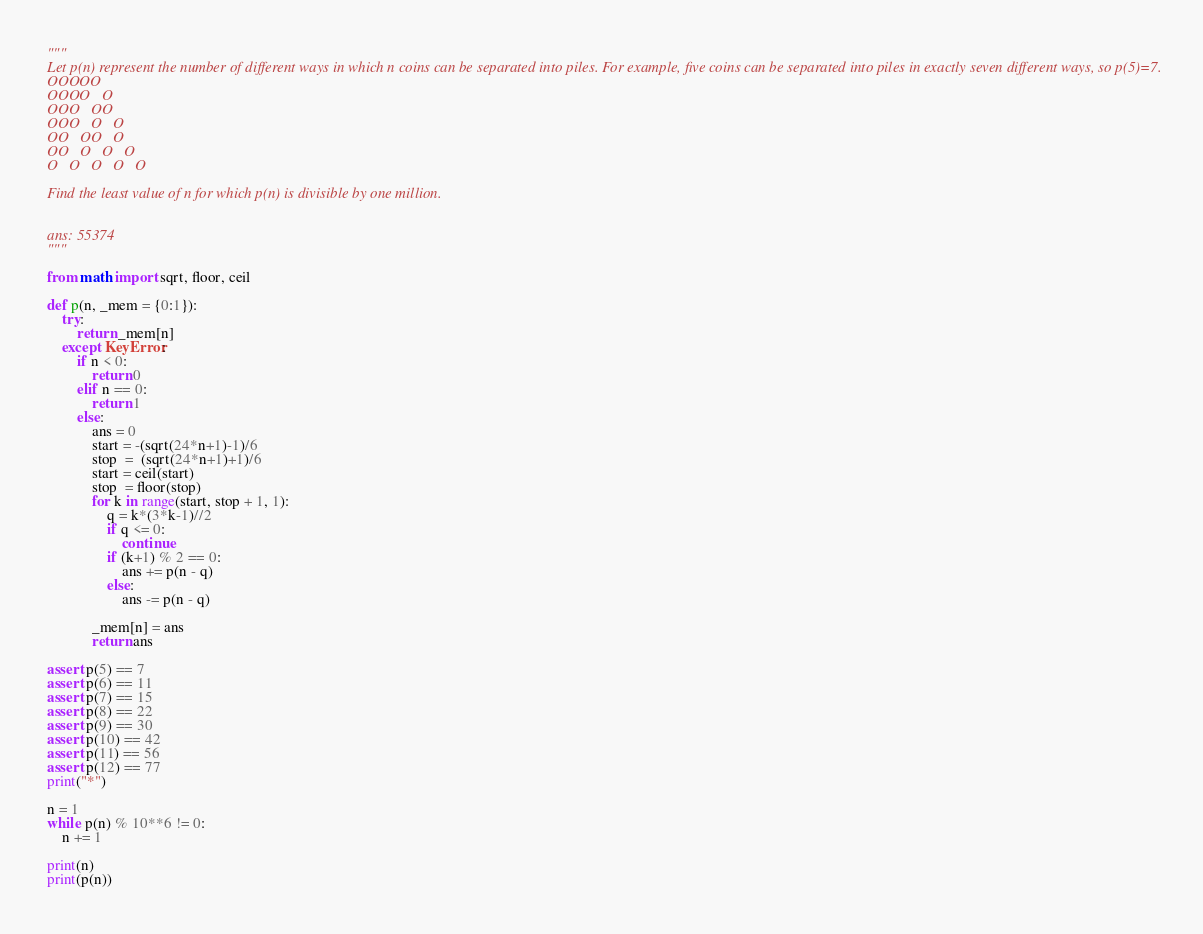<code> <loc_0><loc_0><loc_500><loc_500><_Python_>"""
Let p(n) represent the number of different ways in which n coins can be separated into piles. For example, five coins can be separated into piles in exactly seven different ways, so p(5)=7.
OOOOO
OOOO   O
OOO   OO
OOO   O   O
OO   OO   O
OO   O   O   O
O   O   O   O   O

Find the least value of n for which p(n) is divisible by one million.


ans: 55374
"""

from math import sqrt, floor, ceil

def p(n, _mem = {0:1}):
	try:
		return _mem[n]
	except KeyError:
		if n < 0:
			return 0
		elif n == 0:
			return 1
		else:
			ans = 0
			start = -(sqrt(24*n+1)-1)/6
			stop  =  (sqrt(24*n+1)+1)/6
			start = ceil(start)
			stop  = floor(stop)
			for k in range(start, stop + 1, 1):
				q = k*(3*k-1)//2
				if q <= 0:
					continue				
				if (k+1) % 2 == 0:
					ans += p(n - q)
				else:
					ans -= p(n - q)
					
			_mem[n] = ans
			return ans

assert p(5) == 7
assert p(6) == 11
assert p(7) == 15
assert p(8) == 22
assert p(9) == 30
assert p(10) == 42
assert p(11) == 56
assert p(12) == 77
print("*")

n = 1
while p(n) % 10**6 != 0:
	n += 1

print(n)
print(p(n))</code> 